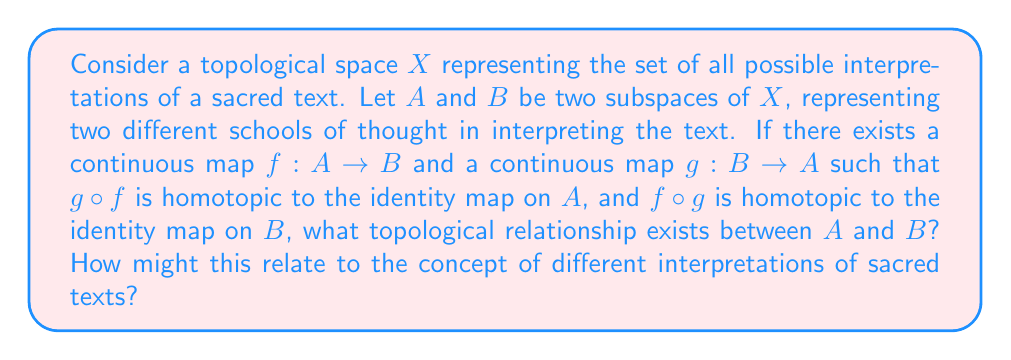Provide a solution to this math problem. To answer this question, we need to understand the concept of homotopy equivalence in topology and its potential application to interpretations of sacred texts.

1. Homotopy equivalence:
   In topology, two spaces $A$ and $B$ are said to be homotopy equivalent if there exist continuous maps $f: A \rightarrow B$ and $g: B \rightarrow A$ such that:
   
   a) $g \circ f$ is homotopic to the identity map on $A$
   b) $f \circ g$ is homotopic to the identity map on $B$

   This is precisely the condition given in the question.

2. Properties of homotopy equivalence:
   Homotopy equivalence is an equivalence relation, meaning it is:
   
   a) Reflexive: Every space is homotopy equivalent to itself
   b) Symmetric: If $A$ is homotopy equivalent to $B$, then $B$ is homotopy equivalent to $A$
   c) Transitive: If $A$ is homotopy equivalent to $B$ and $B$ is homotopy equivalent to $C$, then $A$ is homotopy equivalent to $C$

3. Implications for interpretations of sacred texts:
   In the context of interpreting sacred texts, we can think of homotopy equivalence as representing a fundamental similarity between different interpretations, despite surface-level differences:

   a) The continuous maps $f$ and $g$ represent ways of translating between different interpretations
   b) The homotopies to identity maps suggest that these translations preserve the essential meaning or core principles of each interpretation
   c) The equivalence relation property implies that all interpretations in this relationship share a common essence, even if they appear different on the surface

4. Conclusion:
   Given the conditions in the question, we can conclude that subspaces $A$ and $B$ are homotopy equivalent. In the context of sacred text interpretation, this suggests that the two schools of thought, while possibly appearing different, share a fundamental similarity in their core principles or essential meanings.
Answer: $A$ and $B$ are homotopy equivalent, implying that the two interpretations of the sacred text, while potentially different in their specific expressions, share a fundamental similarity in their core principles or essential meanings. 